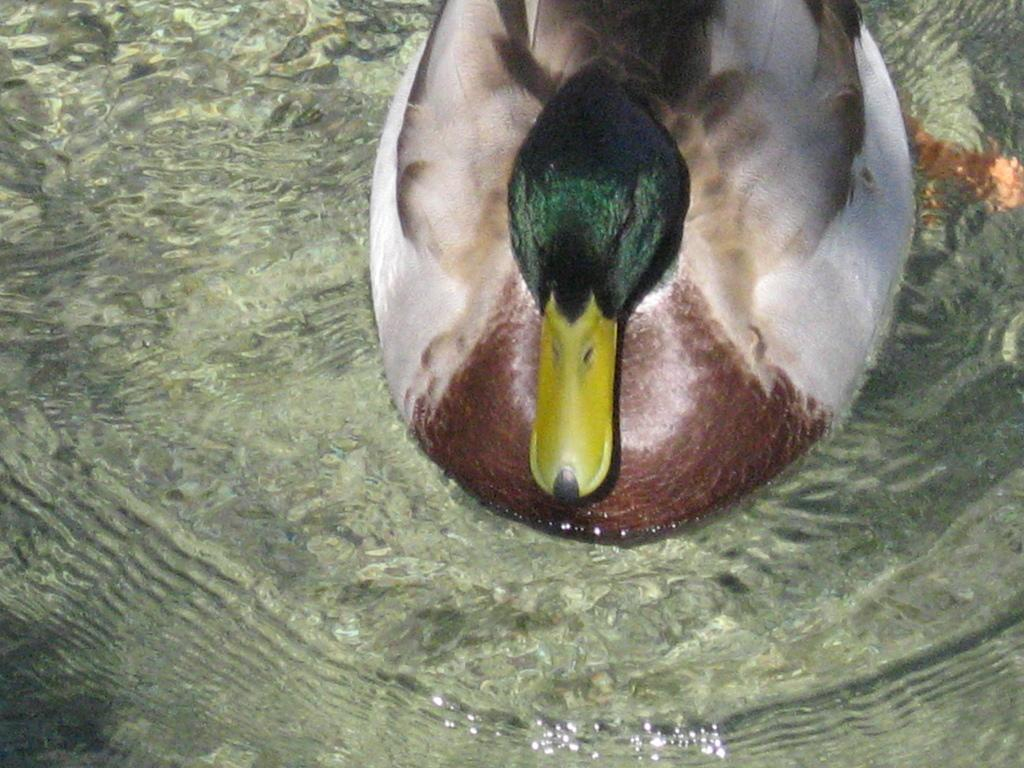What type of animal is in the image? There is a mallard in the image. Where is the mallard located in the image? The mallard is in the water. What type of calculator is floating next to the mallard in the image? There is no calculator present in the image; it only features a mallard in the water. 